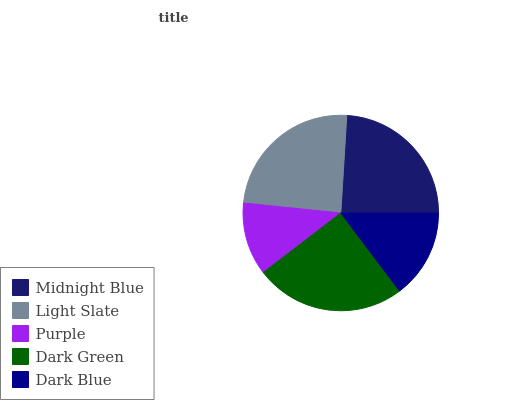Is Purple the minimum?
Answer yes or no. Yes. Is Dark Green the maximum?
Answer yes or no. Yes. Is Light Slate the minimum?
Answer yes or no. No. Is Light Slate the maximum?
Answer yes or no. No. Is Light Slate greater than Midnight Blue?
Answer yes or no. Yes. Is Midnight Blue less than Light Slate?
Answer yes or no. Yes. Is Midnight Blue greater than Light Slate?
Answer yes or no. No. Is Light Slate less than Midnight Blue?
Answer yes or no. No. Is Midnight Blue the high median?
Answer yes or no. Yes. Is Midnight Blue the low median?
Answer yes or no. Yes. Is Purple the high median?
Answer yes or no. No. Is Purple the low median?
Answer yes or no. No. 